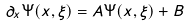<formula> <loc_0><loc_0><loc_500><loc_500>\partial _ { x } \Psi ( x , \xi ) = A \Psi ( x , \xi ) + B</formula> 